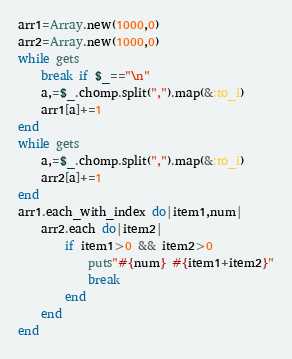<code> <loc_0><loc_0><loc_500><loc_500><_Ruby_>arr1=Array.new(1000,0)
arr2=Array.new(1000,0)
while gets
    break if $_=="\n"
    a,=$_.chomp.split(",").map(&:to_i)
    arr1[a]+=1
end
while gets
    a,=$_.chomp.split(",").map(&:to_i)
    arr2[a]+=1
end
arr1.each_with_index do|item1,num|
    arr2.each do|item2|
        if item1>0 && item2>0
            puts"#{num} #{item1+item2}"
            break
        end
    end
end</code> 